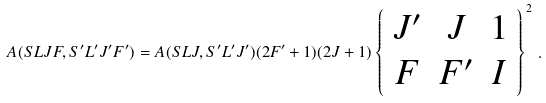Convert formula to latex. <formula><loc_0><loc_0><loc_500><loc_500>A ( S L J F , S ^ { \prime } L ^ { \prime } J ^ { \prime } F ^ { \prime } ) = A ( S L J , S ^ { \prime } L ^ { \prime } J ^ { \prime } ) ( 2 F ^ { \prime } + 1 ) ( 2 J + 1 ) \left \{ \begin{array} { c c c } J ^ { \prime } & J & 1 \\ F & F ^ { \prime } & I \end{array} \right \} ^ { 2 } \, .</formula> 